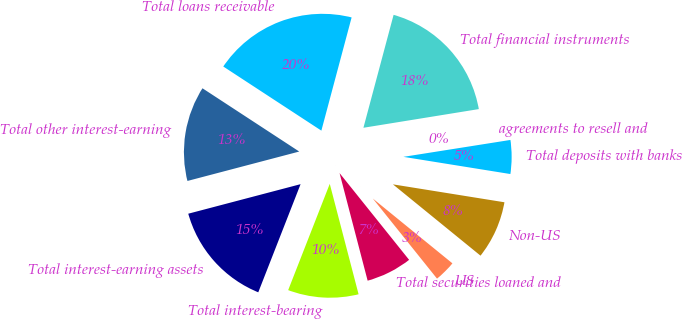<chart> <loc_0><loc_0><loc_500><loc_500><pie_chart><fcel>US<fcel>Non-US<fcel>Total deposits with banks<fcel>agreements to resell and<fcel>Total financial instruments<fcel>Total loans receivable<fcel>Total other interest-earning<fcel>Total interest-earning assets<fcel>Total interest-bearing<fcel>Total securities loaned and<nl><fcel>3.37%<fcel>8.34%<fcel>5.03%<fcel>0.06%<fcel>18.29%<fcel>19.94%<fcel>13.31%<fcel>14.97%<fcel>10.0%<fcel>6.69%<nl></chart> 